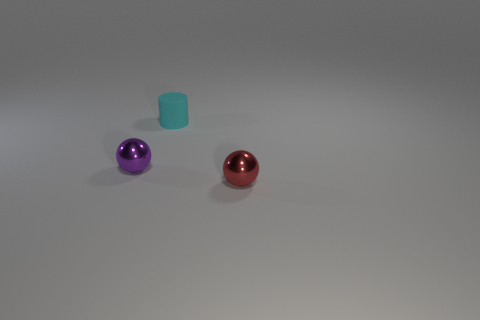Add 3 tiny cyan matte cylinders. How many objects exist? 6 Subtract all cylinders. How many objects are left? 2 Subtract all matte cylinders. Subtract all red metal things. How many objects are left? 1 Add 2 balls. How many balls are left? 4 Add 2 small matte spheres. How many small matte spheres exist? 2 Subtract 0 red cylinders. How many objects are left? 3 